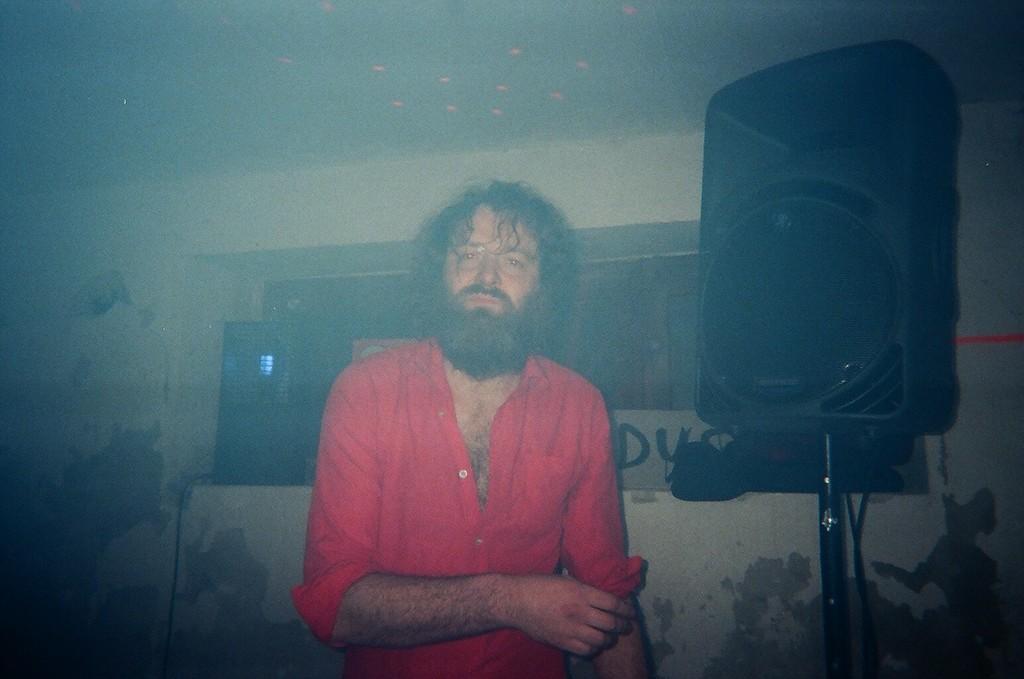In one or two sentences, can you explain what this image depicts? In the image there is a man he is wearing red shirt and there is a speaker beside him and in the background there is a wall and there are few windows in between the wall. 